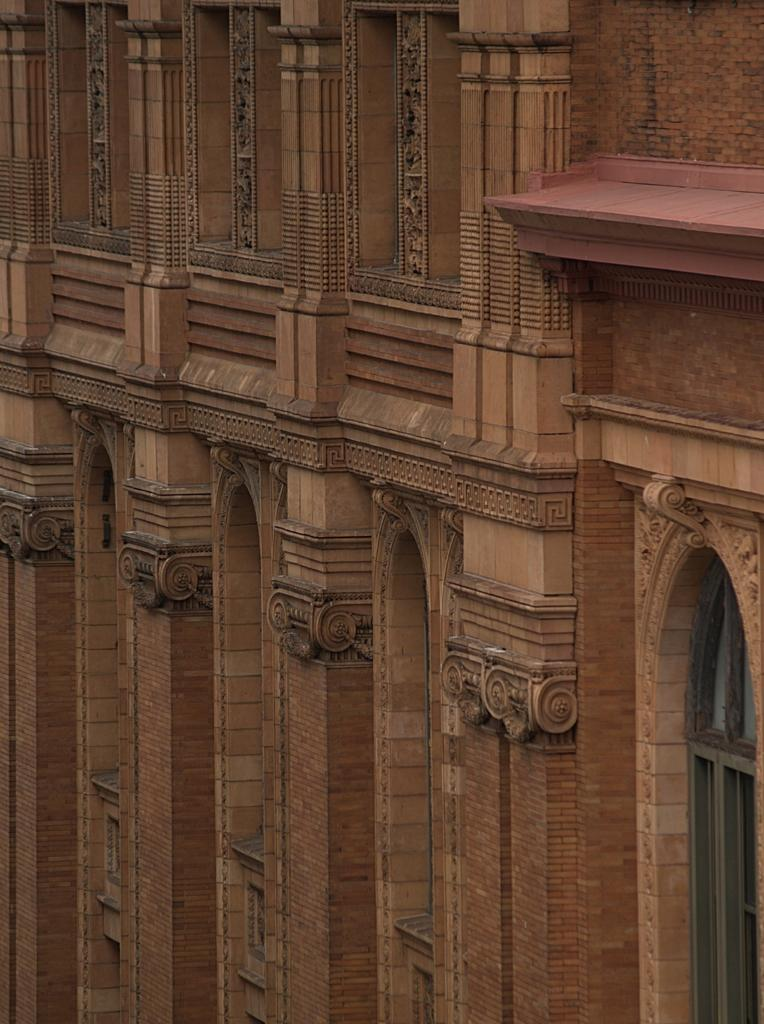What type of structure is present in the image? There is a building in the image. What material is the building made of? The building is made up of bricks. What is the color of the building? The building is brown in color. Where is the window located on the building? There is a window on the right side of the building. What architectural features can be seen in the image? There are pillars visible in the image. Can you see a ghost sitting on the seat in the image? There is no ghost or seat present in the image. 